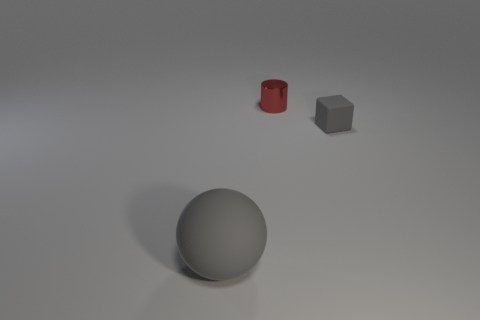Is there any other thing that has the same size as the gray ball?
Your answer should be compact. No. How many large gray things are the same material as the small gray cube?
Make the answer very short. 1. Do the matte thing on the left side of the tiny red object and the rubber cube have the same color?
Your response must be concise. Yes. What number of red objects are matte balls or tiny shiny cylinders?
Ensure brevity in your answer.  1. Is there anything else that has the same material as the red thing?
Offer a very short reply. No. Do the gray object in front of the tiny gray cube and the gray cube have the same material?
Offer a very short reply. Yes. How many things are large blue shiny objects or gray objects that are right of the sphere?
Provide a succinct answer. 1. There is a gray rubber thing that is on the left side of the tiny thing to the left of the cube; what number of cubes are behind it?
Provide a short and direct response. 1. Are there any gray rubber objects that are in front of the gray rubber thing to the right of the ball?
Offer a terse response. Yes. What number of large gray spheres are there?
Your response must be concise. 1. 